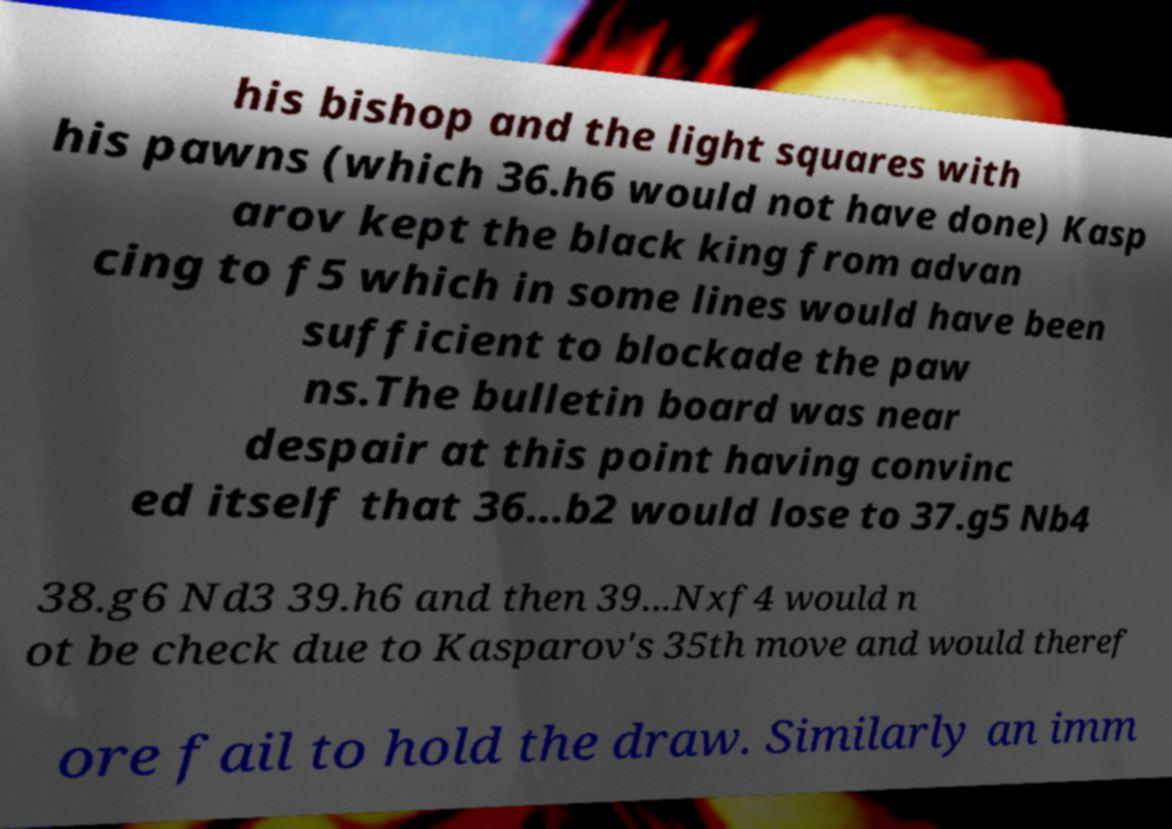What messages or text are displayed in this image? I need them in a readable, typed format. his bishop and the light squares with his pawns (which 36.h6 would not have done) Kasp arov kept the black king from advan cing to f5 which in some lines would have been sufficient to blockade the paw ns.The bulletin board was near despair at this point having convinc ed itself that 36...b2 would lose to 37.g5 Nb4 38.g6 Nd3 39.h6 and then 39...Nxf4 would n ot be check due to Kasparov's 35th move and would theref ore fail to hold the draw. Similarly an imm 